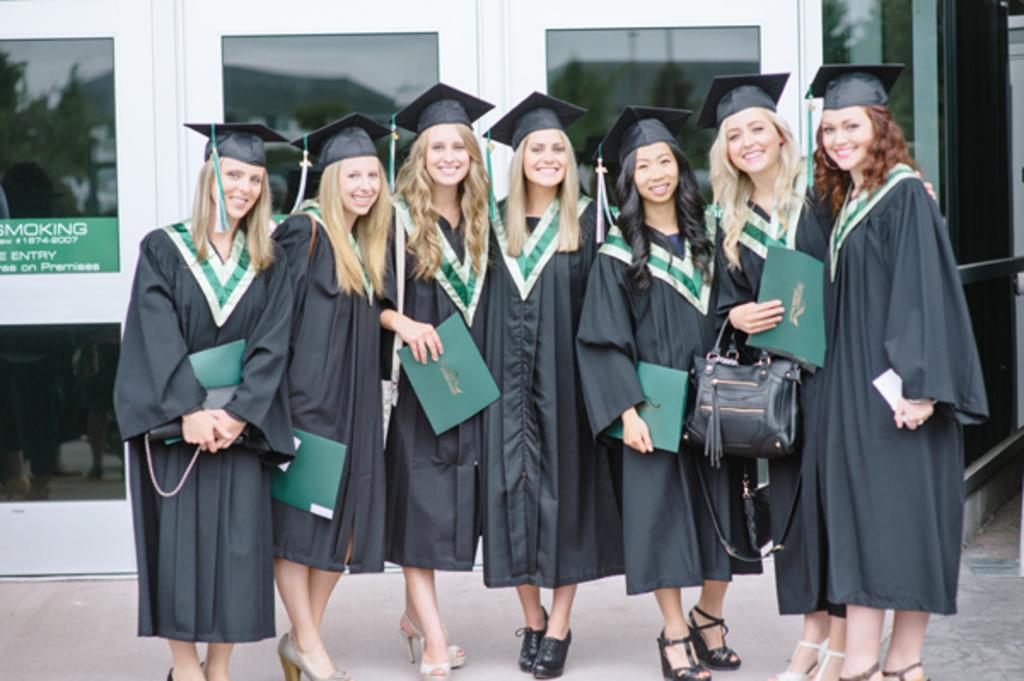What are the women in the image doing? The women are posing for a camera in the image. What is the facial expression of the women? The women are smiling in the image. What can be seen behind the women? There is a background visible in the image, which includes glasses and a board. What type of balloon is being used for the voyage in the image? There is no balloon or voyage present in the image; it features women posing for a camera with a background that includes glasses and a board. 